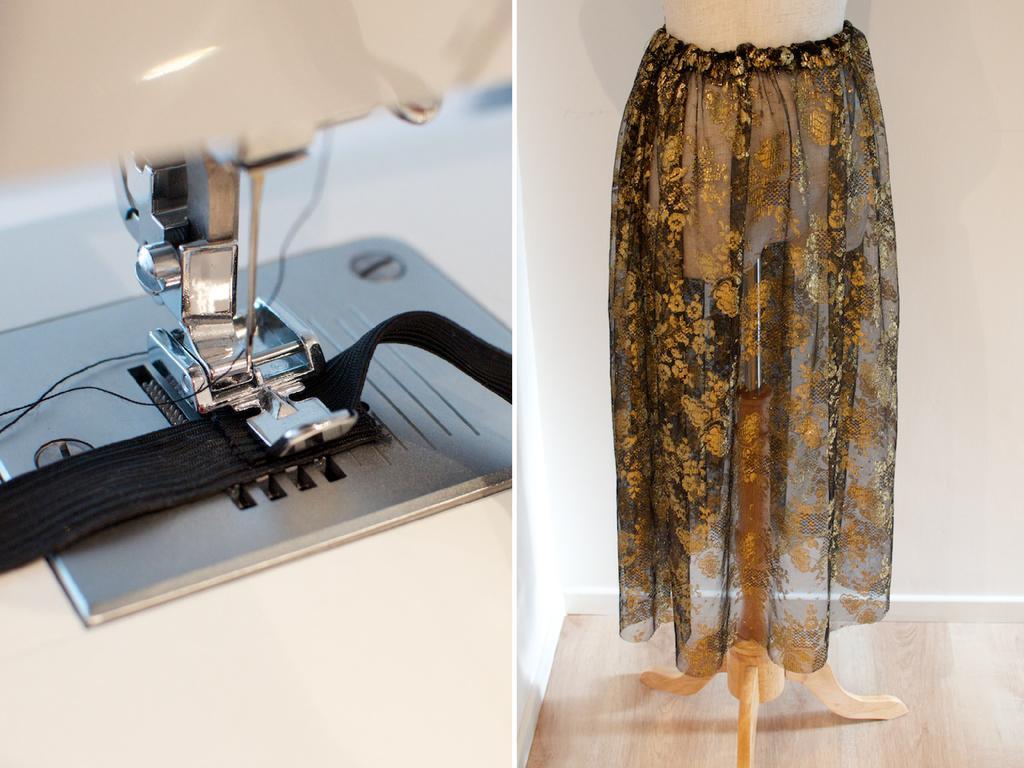Describe this image in one or two sentences. In this picture I can see collage of couple of pictures, In the first picture I can see a sewing machine and in the second picture I can see a cloth to the stand. 